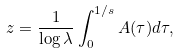Convert formula to latex. <formula><loc_0><loc_0><loc_500><loc_500>z = \frac { 1 } { \log \lambda } \int _ { 0 } ^ { 1 / s } A ( \tau ) d \tau ,</formula> 